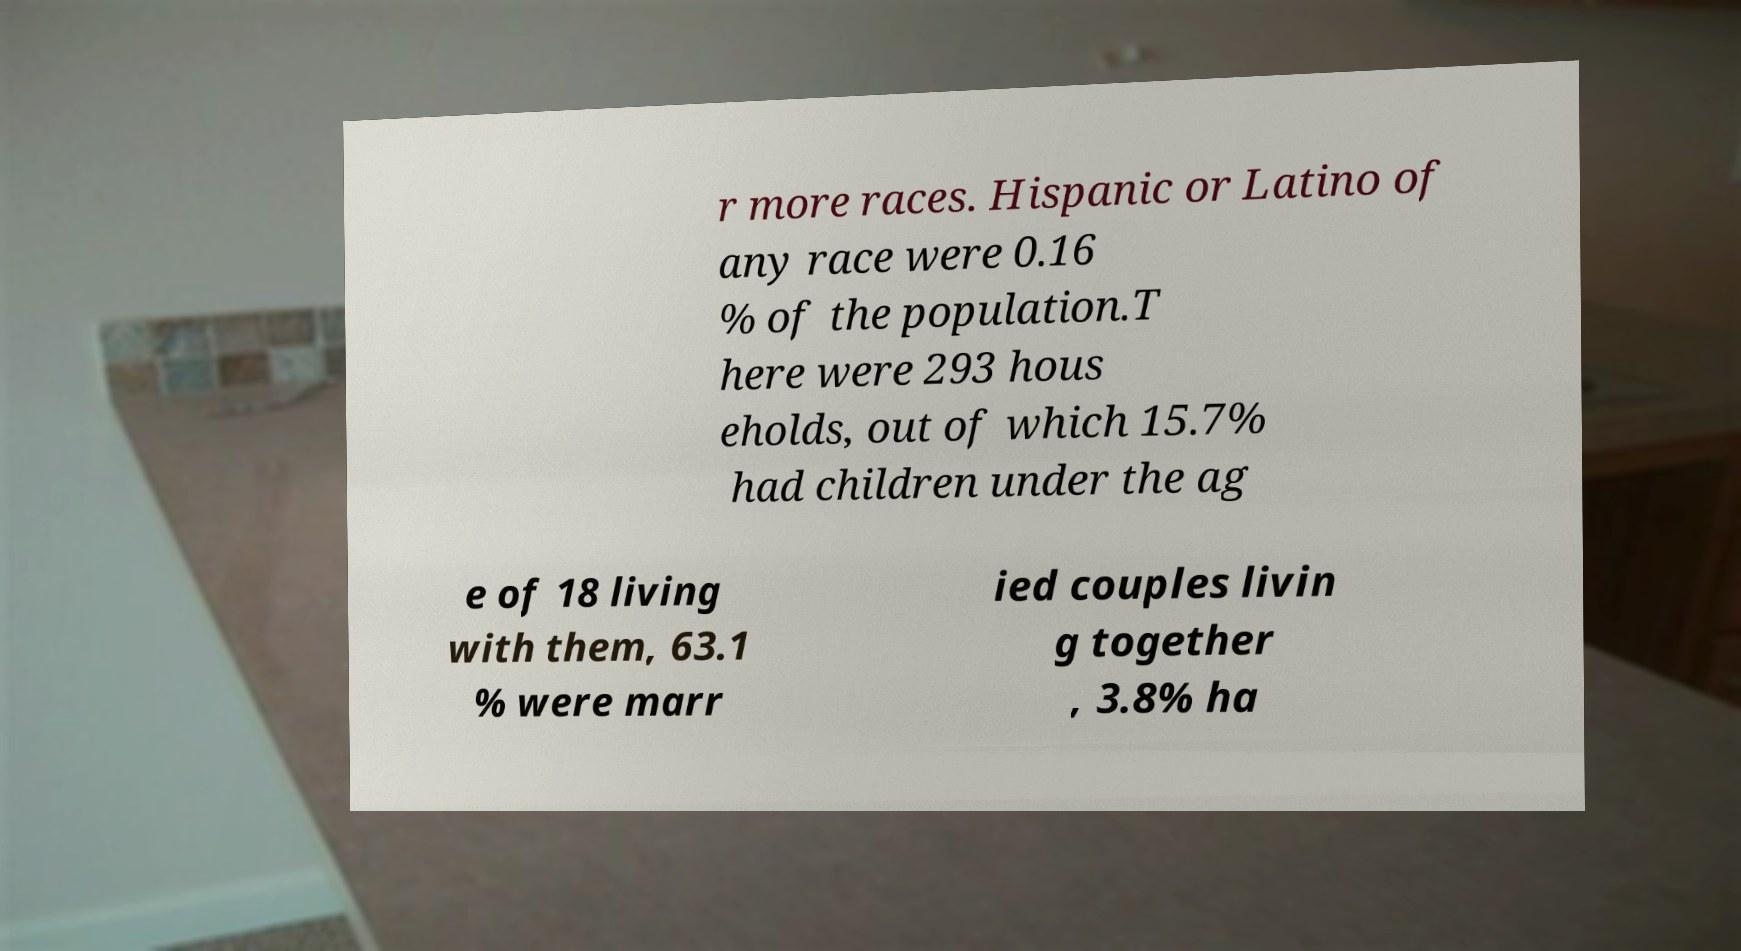For documentation purposes, I need the text within this image transcribed. Could you provide that? r more races. Hispanic or Latino of any race were 0.16 % of the population.T here were 293 hous eholds, out of which 15.7% had children under the ag e of 18 living with them, 63.1 % were marr ied couples livin g together , 3.8% ha 